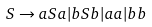Convert formula to latex. <formula><loc_0><loc_0><loc_500><loc_500>S \rightarrow a S a | b S b | a a | b b</formula> 